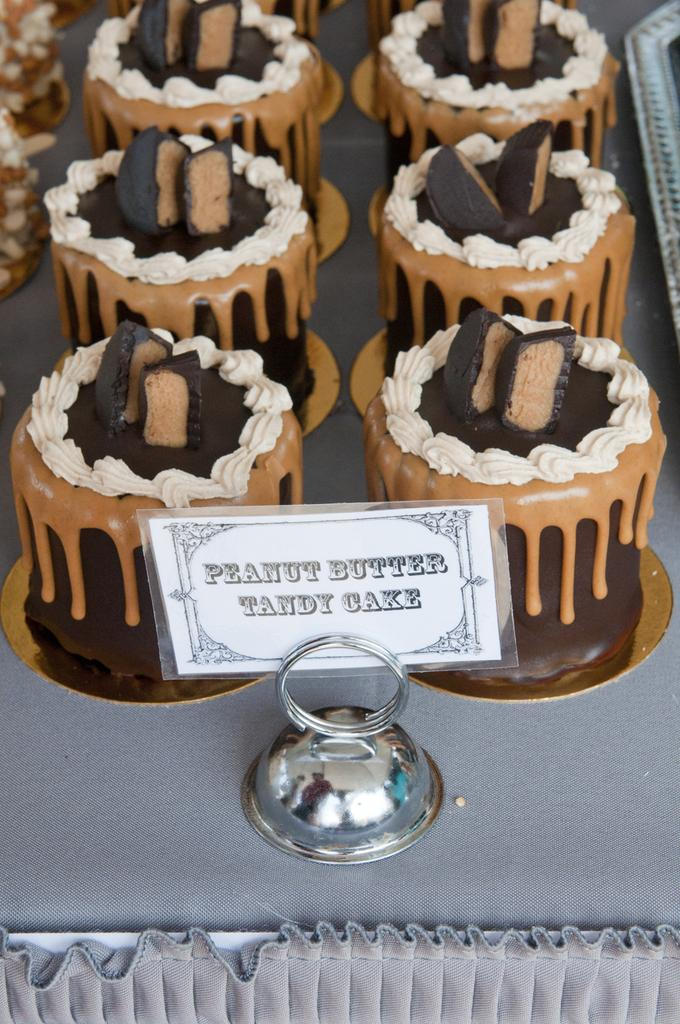What type of food can be seen in the image? There are cakes placed in a row in the image. What else is present in the image besides the cakes? There is an information board in the image. What color are the toes of the person sitting on the sofa in the image? There is no sofa or person with toes present in the image; it only features cakes and an information board. 